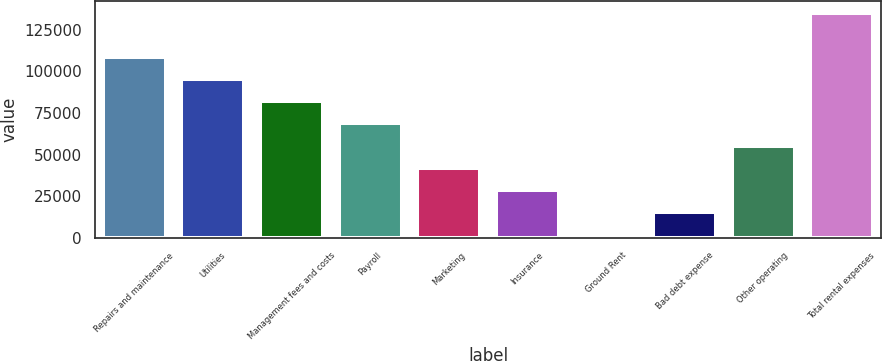Convert chart. <chart><loc_0><loc_0><loc_500><loc_500><bar_chart><fcel>Repairs and maintenance<fcel>Utilities<fcel>Management fees and costs<fcel>Payroll<fcel>Marketing<fcel>Insurance<fcel>Ground Rent<fcel>Bad debt expense<fcel>Other operating<fcel>Total rental expenses<nl><fcel>108724<fcel>95377.5<fcel>82031<fcel>68684.5<fcel>41991.5<fcel>28645<fcel>1952<fcel>15298.5<fcel>55338<fcel>135417<nl></chart> 